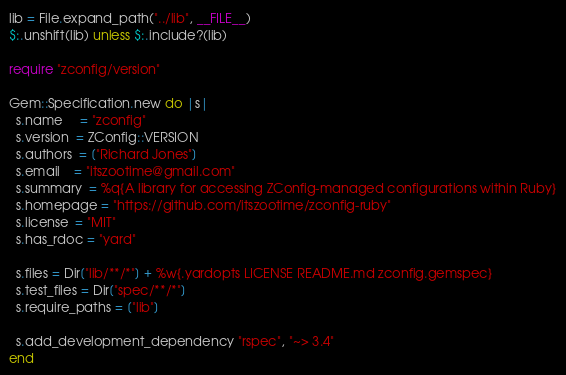<code> <loc_0><loc_0><loc_500><loc_500><_Ruby_>lib = File.expand_path("../lib", __FILE__)
$:.unshift(lib) unless $:.include?(lib)

require "zconfig/version"

Gem::Specification.new do |s|
  s.name     = "zconfig"
  s.version  = ZConfig::VERSION
  s.authors  = ["Richard Jones"]
  s.email    = "itszootime@gmail.com"
  s.summary  = %q{A library for accessing ZConfig-managed configurations within Ruby}
  s.homepage = "https://github.com/itszootime/zconfig-ruby"
  s.license  = "MIT"
  s.has_rdoc = "yard"

  s.files = Dir["lib/**/*"] + %w{.yardopts LICENSE README.md zconfig.gemspec}
  s.test_files = Dir["spec/**/*"]
  s.require_paths = ["lib"]

  s.add_development_dependency "rspec", "~> 3.4"
end
</code> 